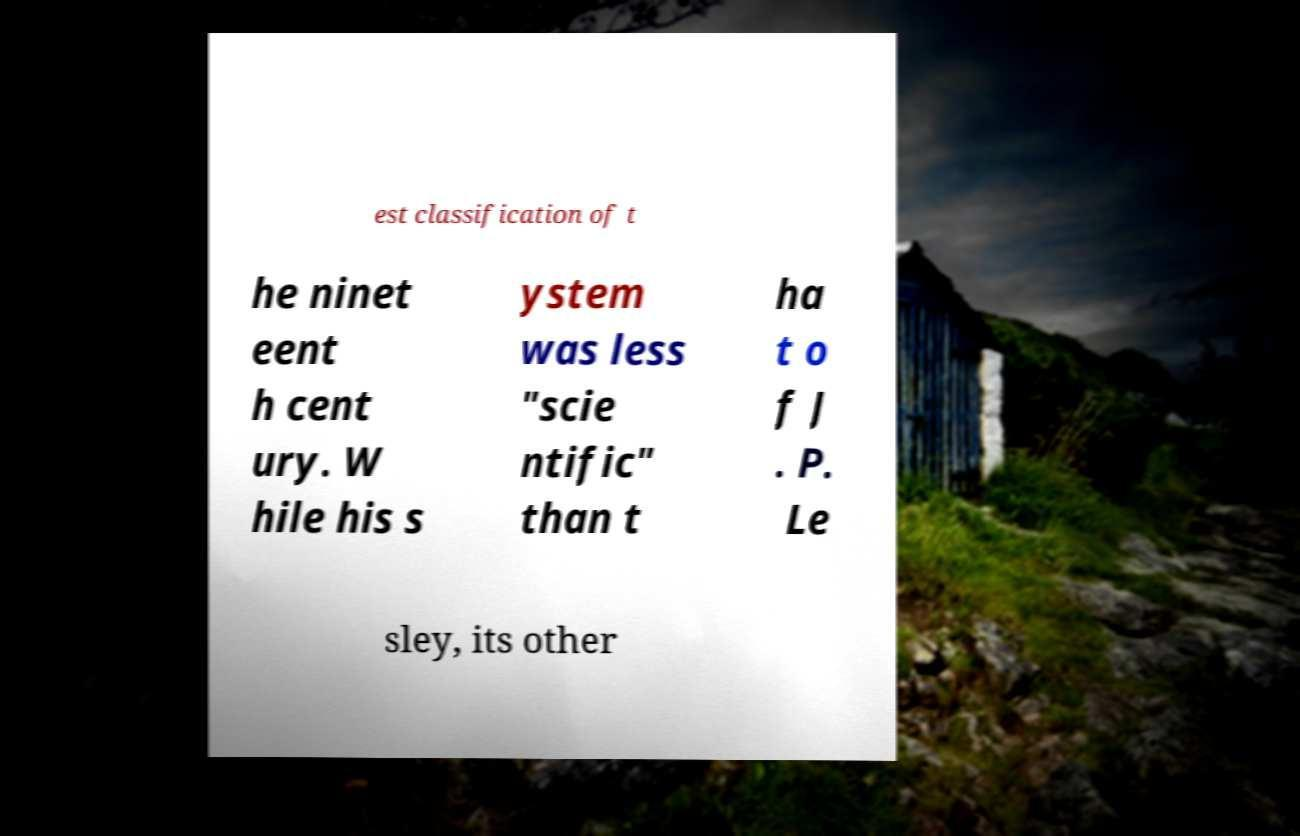Can you accurately transcribe the text from the provided image for me? est classification of t he ninet eent h cent ury. W hile his s ystem was less "scie ntific" than t ha t o f J . P. Le sley, its other 